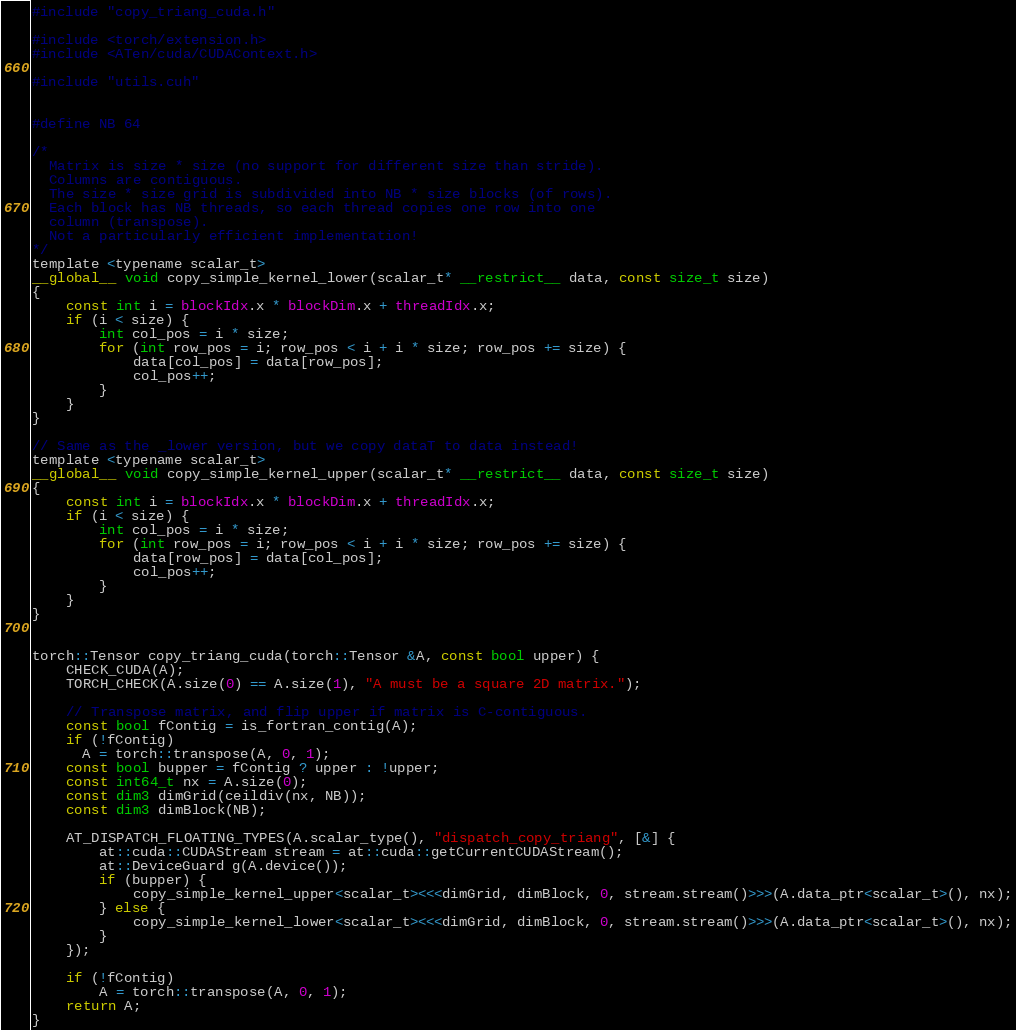Convert code to text. <code><loc_0><loc_0><loc_500><loc_500><_Cuda_>#include "copy_triang_cuda.h"

#include <torch/extension.h>
#include <ATen/cuda/CUDAContext.h>

#include "utils.cuh"


#define NB 64

/*
  Matrix is size * size (no support for different size than stride).
  Columns are contiguous.
  The size * size grid is subdivided into NB * size blocks (of rows).
  Each block has NB threads, so each thread copies one row into one
  column (transpose).
  Not a particularly efficient implementation!
*/
template <typename scalar_t>
__global__ void copy_simple_kernel_lower(scalar_t* __restrict__ data, const size_t size)
{
    const int i = blockIdx.x * blockDim.x + threadIdx.x;
    if (i < size) {
        int col_pos = i * size;
        for (int row_pos = i; row_pos < i + i * size; row_pos += size) {
            data[col_pos] = data[row_pos];
            col_pos++;
        }
    }
}

// Same as the _lower version, but we copy dataT to data instead!
template <typename scalar_t>
__global__ void copy_simple_kernel_upper(scalar_t* __restrict__ data, const size_t size)
{
    const int i = blockIdx.x * blockDim.x + threadIdx.x;
    if (i < size) {
        int col_pos = i * size;
        for (int row_pos = i; row_pos < i + i * size; row_pos += size) {
            data[row_pos] = data[col_pos];
            col_pos++;
        }
    }
}


torch::Tensor copy_triang_cuda(torch::Tensor &A, const bool upper) {
    CHECK_CUDA(A);
    TORCH_CHECK(A.size(0) == A.size(1), "A must be a square 2D matrix.");

    // Transpose matrix, and flip upper if matrix is C-contiguous.
    const bool fContig = is_fortran_contig(A);
    if (!fContig)
      A = torch::transpose(A, 0, 1);
    const bool bupper = fContig ? upper : !upper;
    const int64_t nx = A.size(0);
    const dim3 dimGrid(ceildiv(nx, NB));
    const dim3 dimBlock(NB);

    AT_DISPATCH_FLOATING_TYPES(A.scalar_type(), "dispatch_copy_triang", [&] {
        at::cuda::CUDAStream stream = at::cuda::getCurrentCUDAStream();
        at::DeviceGuard g(A.device());
        if (bupper) {
            copy_simple_kernel_upper<scalar_t><<<dimGrid, dimBlock, 0, stream.stream()>>>(A.data_ptr<scalar_t>(), nx);
        } else {
            copy_simple_kernel_lower<scalar_t><<<dimGrid, dimBlock, 0, stream.stream()>>>(A.data_ptr<scalar_t>(), nx);
        }
    });

    if (!fContig)
        A = torch::transpose(A, 0, 1);
    return A;
}
</code> 